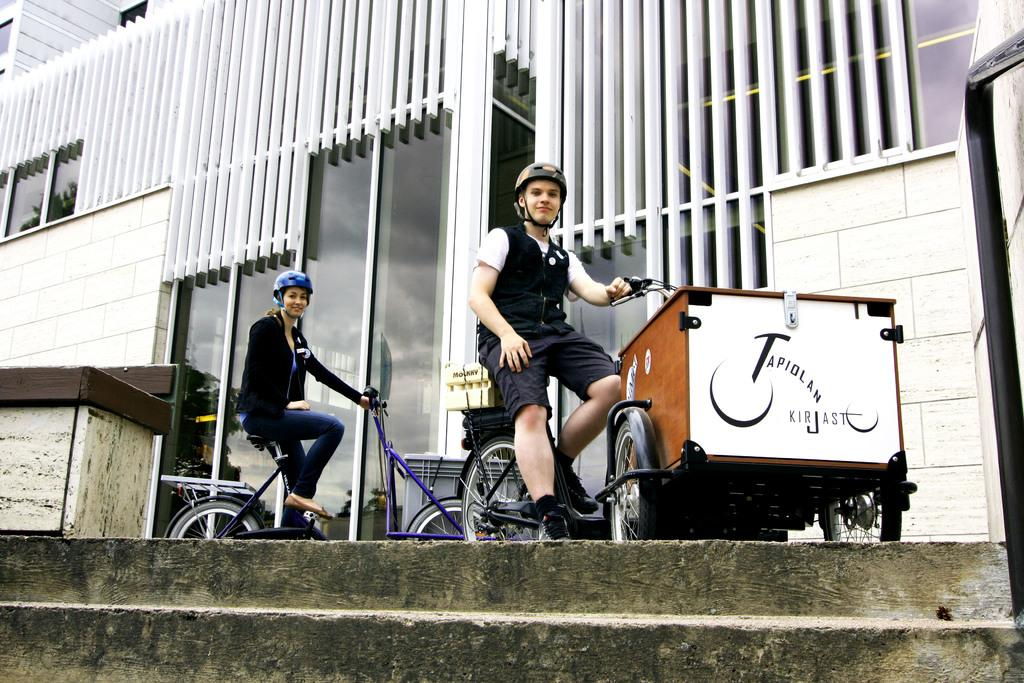What can be seen in the image that people use to move between different levels? There are visible in the image. What is the person sitting on in the image? The person is sitting on a vehicle. What type of protective gear is the person wearing? The person is wearing a helmet. Who else is present in the image besides the person on the vehicle? There is a girl in the image. What type of barrier can be seen in the image? There is a glass wall in the image. What type of education is the person on the vehicle pursuing in the image? There is no indication of education in the image; it primarily features a person sitting on a vehicle, wearing a helmet, and a girl standing nearby. What kind of breakfast is the girl eating in the image? There is no breakfast visible in the image; it primarily features a person sitting on a vehicle, wearing a helmet, and a girl standing nearby. 